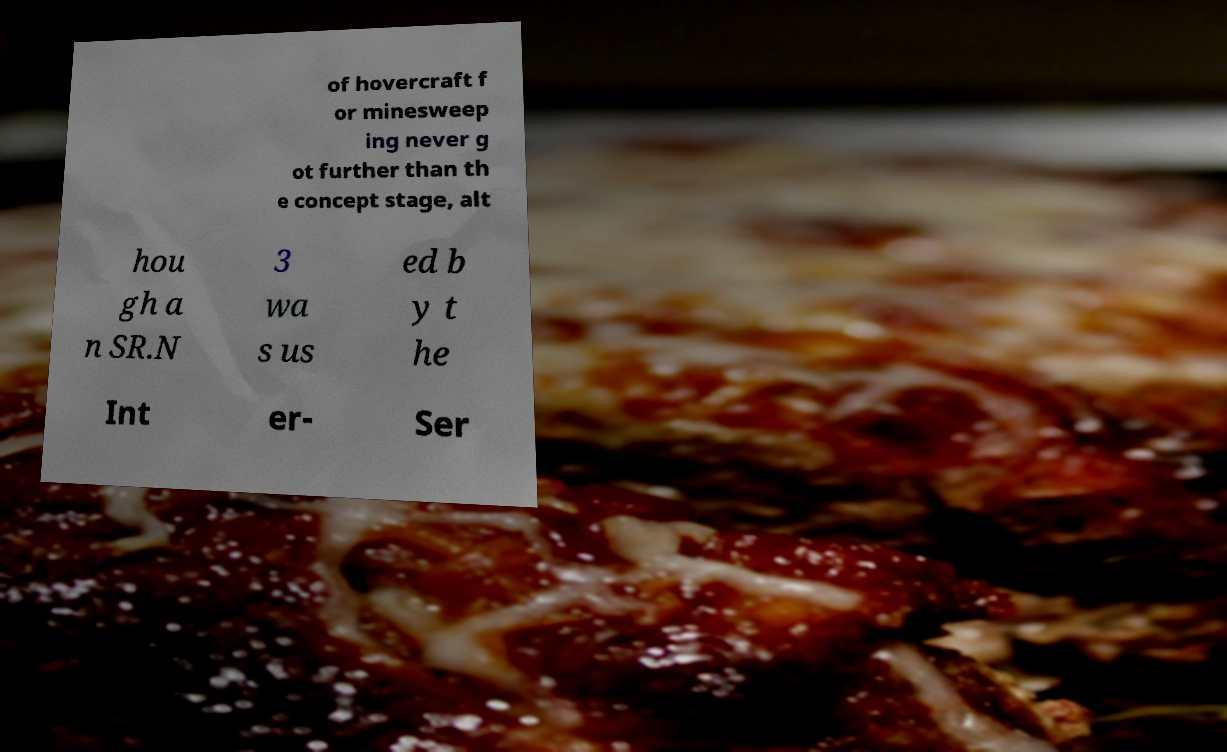For documentation purposes, I need the text within this image transcribed. Could you provide that? of hovercraft f or minesweep ing never g ot further than th e concept stage, alt hou gh a n SR.N 3 wa s us ed b y t he Int er- Ser 